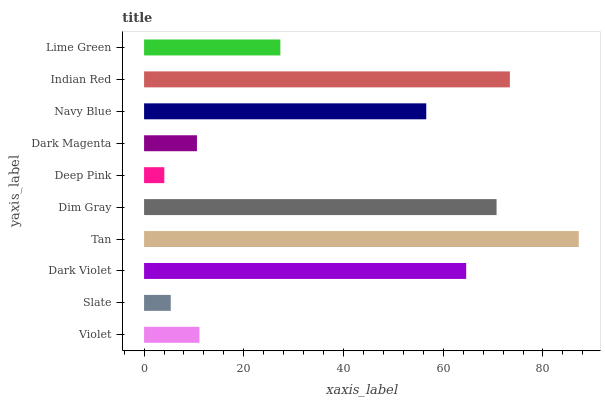Is Deep Pink the minimum?
Answer yes or no. Yes. Is Tan the maximum?
Answer yes or no. Yes. Is Slate the minimum?
Answer yes or no. No. Is Slate the maximum?
Answer yes or no. No. Is Violet greater than Slate?
Answer yes or no. Yes. Is Slate less than Violet?
Answer yes or no. Yes. Is Slate greater than Violet?
Answer yes or no. No. Is Violet less than Slate?
Answer yes or no. No. Is Navy Blue the high median?
Answer yes or no. Yes. Is Lime Green the low median?
Answer yes or no. Yes. Is Deep Pink the high median?
Answer yes or no. No. Is Tan the low median?
Answer yes or no. No. 